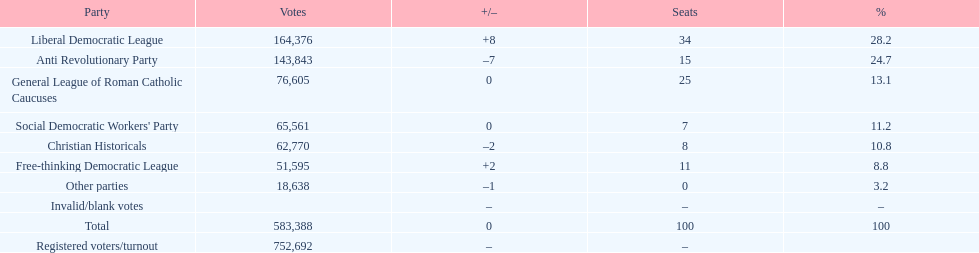Name the top three parties? Liberal Democratic League, Anti Revolutionary Party, General League of Roman Catholic Caucuses. 